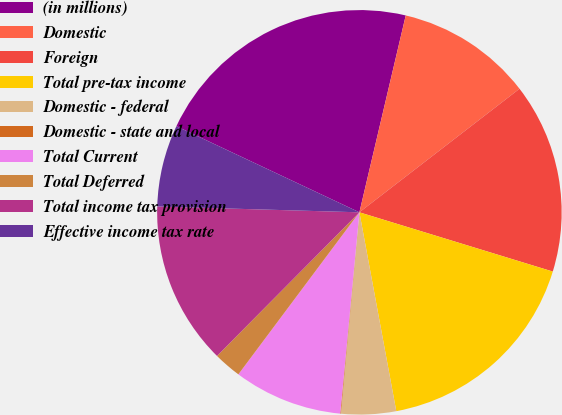<chart> <loc_0><loc_0><loc_500><loc_500><pie_chart><fcel>(in millions)<fcel>Domestic<fcel>Foreign<fcel>Total pre-tax income<fcel>Domestic - federal<fcel>Domestic - state and local<fcel>Total Current<fcel>Total Deferred<fcel>Total income tax provision<fcel>Effective income tax rate<nl><fcel>21.68%<fcel>10.86%<fcel>15.19%<fcel>17.35%<fcel>4.38%<fcel>0.05%<fcel>8.7%<fcel>2.22%<fcel>13.03%<fcel>6.54%<nl></chart> 